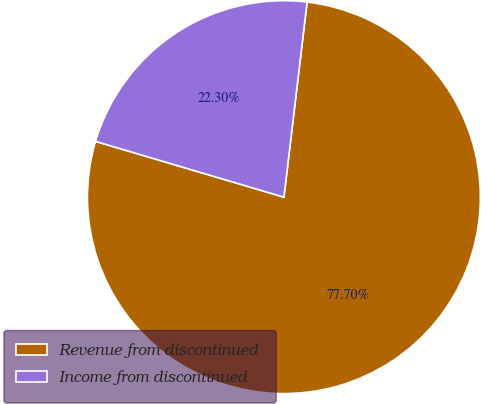<chart> <loc_0><loc_0><loc_500><loc_500><pie_chart><fcel>Revenue from discontinued<fcel>Income from discontinued<nl><fcel>77.7%<fcel>22.3%<nl></chart> 